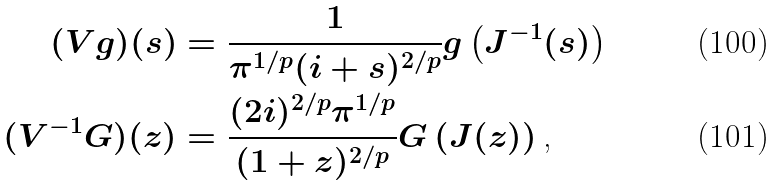Convert formula to latex. <formula><loc_0><loc_0><loc_500><loc_500>( V g ) ( s ) & = \frac { 1 } { \pi ^ { 1 / p } ( i + s ) ^ { 2 / p } } g \left ( J ^ { - 1 } ( s ) \right ) \\ ( V ^ { - 1 } G ) ( z ) & = \frac { ( 2 i ) ^ { 2 / p } \pi ^ { 1 / p } } { ( 1 + z ) ^ { 2 / p } } G \left ( J ( z ) \right ) \text {,}</formula> 